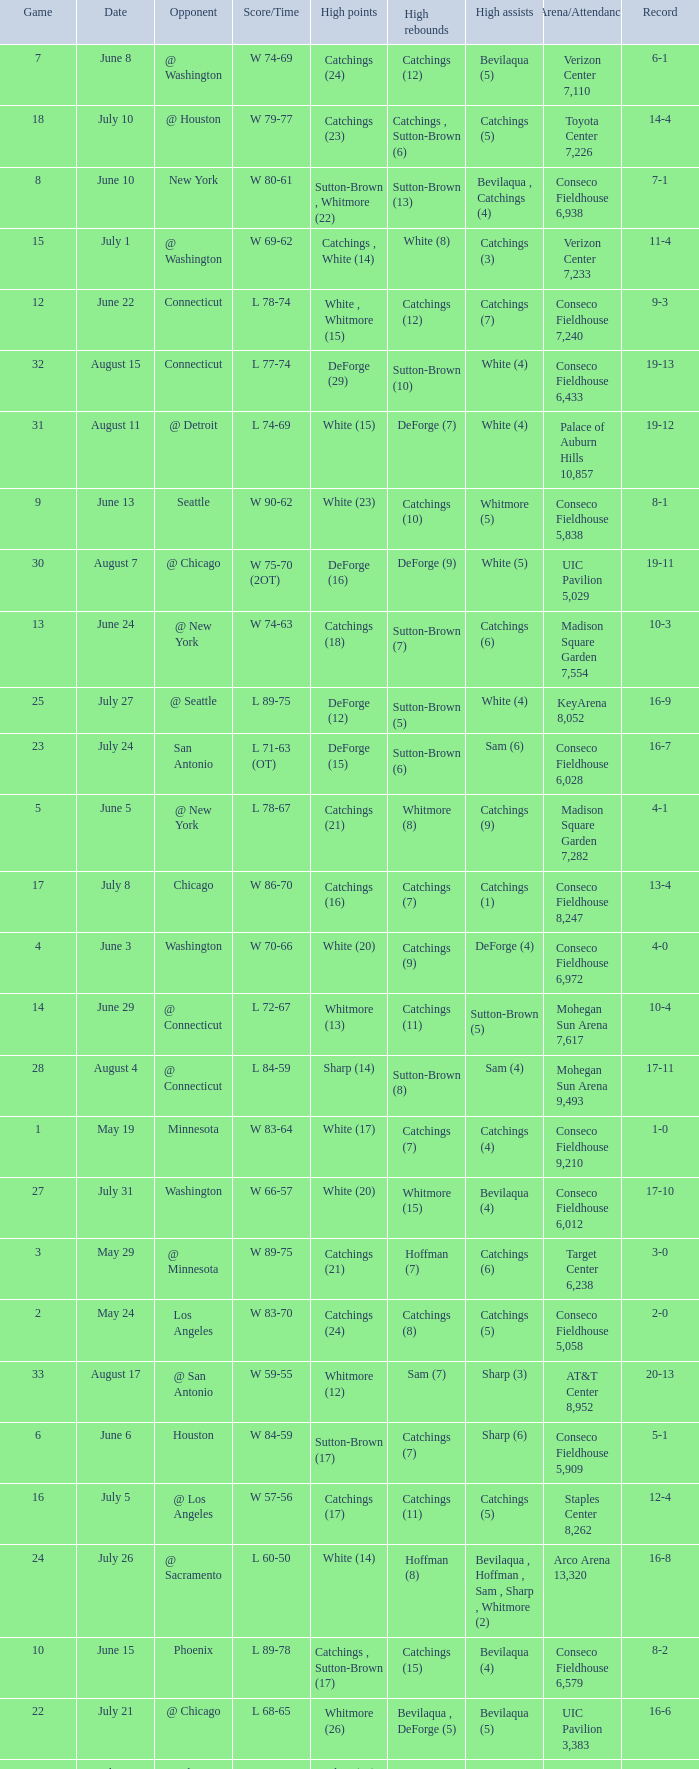Name the total number of opponent of record 9-2 1.0. 